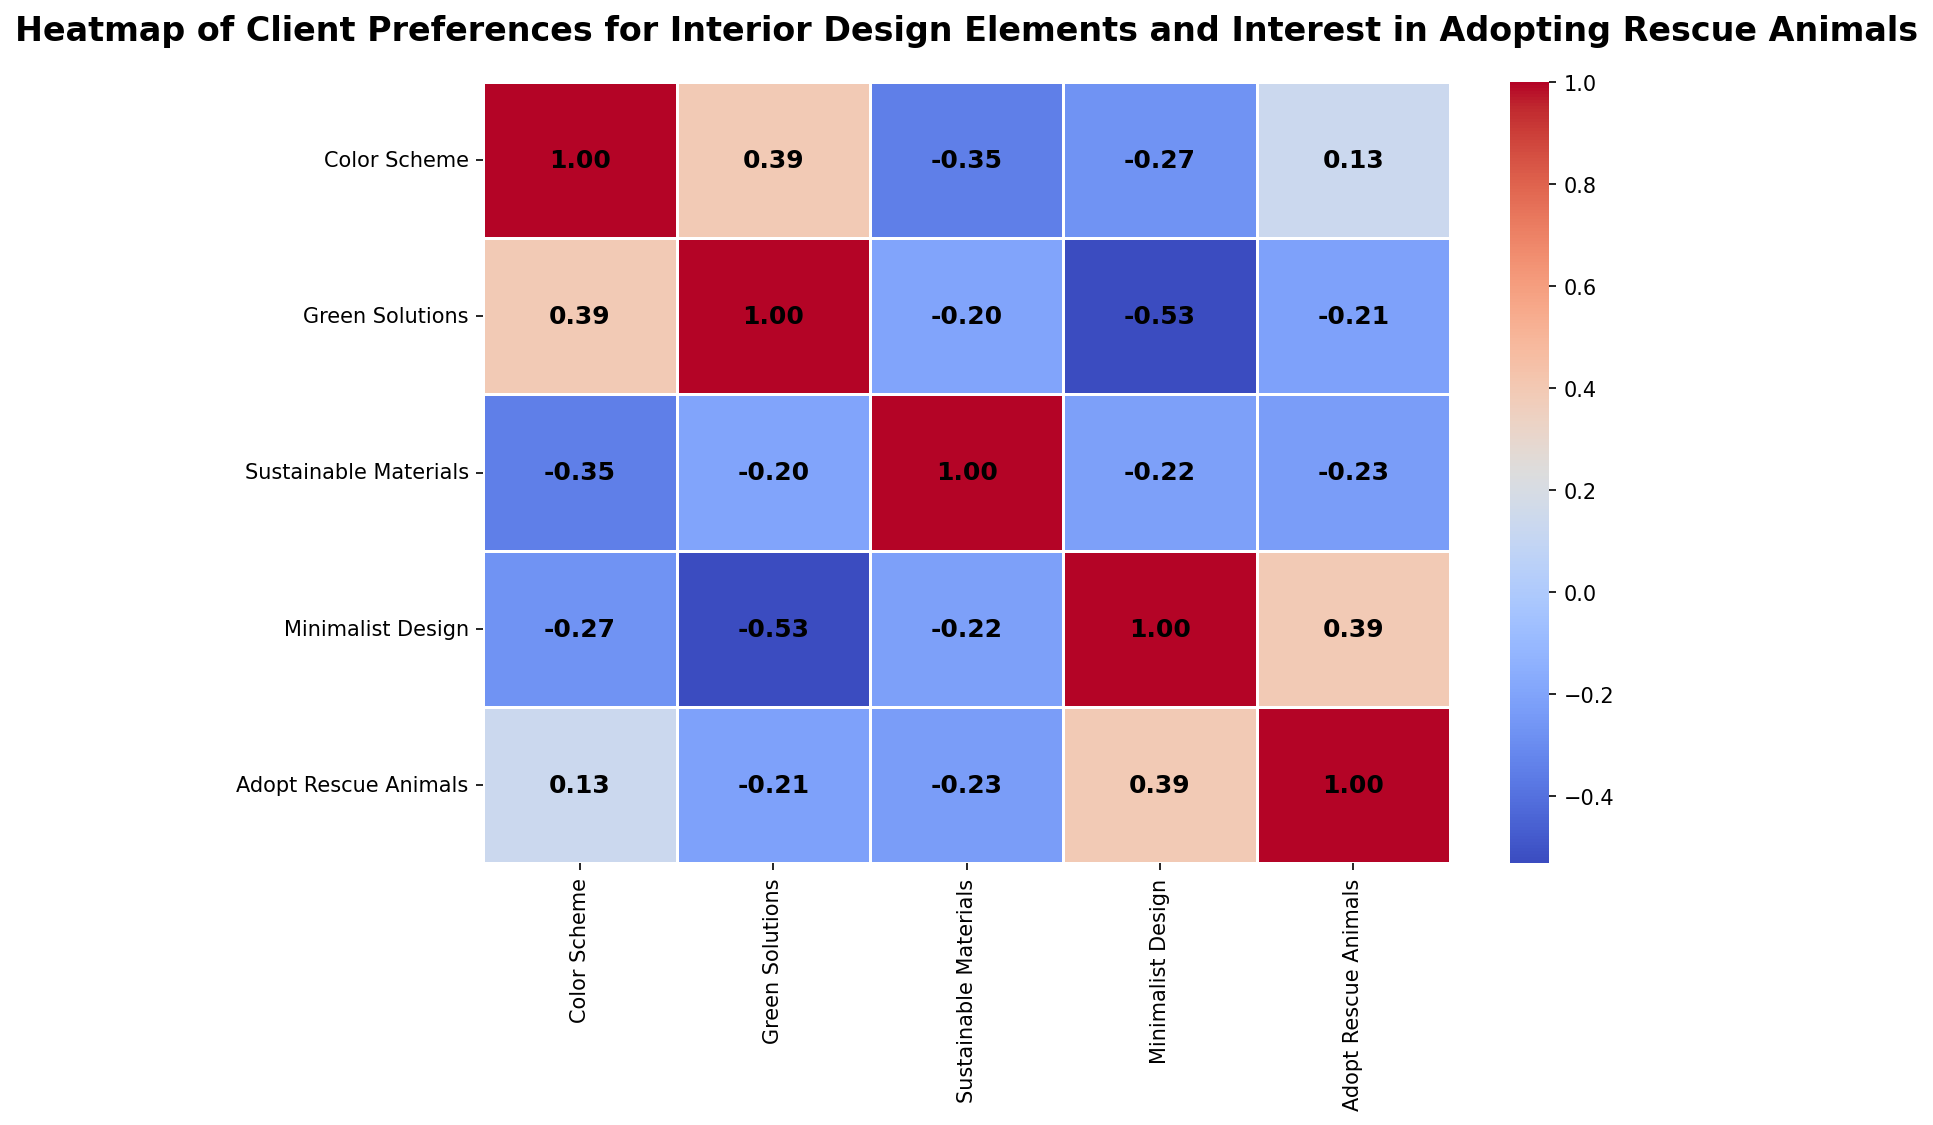What's the highest correlated pair of variables? To find the pair of variables with the highest correlation, look for the largest value in the heatmap excluding the diagonal of 1s. The highest correlation (0.82) is between "Green Solutions" and "Sustainable Materials."
Answer: Green Solutions and Sustainable Materials Which design element has the strongest correlation with interest in adopting rescue animals? Look at the row/column for "Adopt Rescue Animals" and identify the largest correlation value. The highest correlation is 0.51, between "Minimalist Design" and "Adopt Rescue Animals."
Answer: Minimalist Design Which two variables have the lowest correlation? To find the pair of variables with the lowest correlation, look for the smallest value in the heatmap. The lowest correlation (-0.02) is between "Green Solutions" and "Minimalist Design."
Answer: Green Solutions and Minimalist Design Is the interest in adopting rescue animals more strongly correlated with "Color Scheme" or "Sustainable Materials"? Compare the correlation values of "Adopt Rescue Animals" with "Color Scheme" and "Sustainable Materials." The values are 0.34 and 0.39 respectively, so it's more strongly correlated with "Sustainable Materials."
Answer: Sustainable Materials Does "Color Scheme" have a positive or negative correlation with "Minimalist Design"? Look at the intersection of "Color Scheme" and "Minimalist Design" in the heatmap. The correlation value is 0.14, indicating a positive correlation.
Answer: Positive What’s the average correlation of "Green Solutions" with all other variables? Sum the correlation values of "Green Solutions" with all other variables and divide by the number of variables. The values are: 0.33, 0.65, 0.82, -0.02, and 0.39. Sum is 0.33 + 0.65 + 0.82 - 0.02 + 0.39 = 2.17. Average is 2.17/5 = 0.43.
Answer: 0.43 Which variables exhibit a higher correlation, "Color Scheme" and "Sustainable Materials" or "Color Scheme" and "Adopt Rescue Animals"? Compare the correlation values; "Color Scheme" with "Sustainable Materials" is 0.37 and with "Adopt Rescue Animals" is 0.34. So, "Color Scheme" and "Sustainable Materials" exhibit a higher correlation.
Answer: Color Scheme and Sustainable Materials Does "Sustainable Materials" have any correlations stronger than 0.8 with other variables? Examine the "Sustainable Materials" row/column for values above 0.8. The only value that matches this criterion is with "Green Solutions" at 0.82.
Answer: Yes Which correlation value is higher: between "Minimalist Design" and "Green Solutions" or between "Minimalist Design" and "Sustainable Materials"? Compare the two correlation values: "Minimalist Design" and "Green Solutions" is -0.02, and "Minimalist Design" and "Sustainable Materials" is 0.10. Therefore, "Minimalist Design" and "Sustainable Materials" have a slightly higher correlation.
Answer: Minimalist Design and Sustainable Materials 